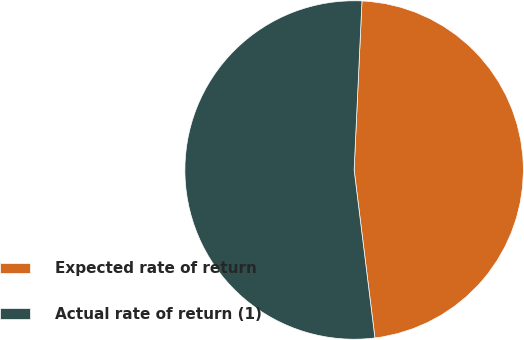<chart> <loc_0><loc_0><loc_500><loc_500><pie_chart><fcel>Expected rate of return<fcel>Actual rate of return (1)<nl><fcel>47.3%<fcel>52.7%<nl></chart> 